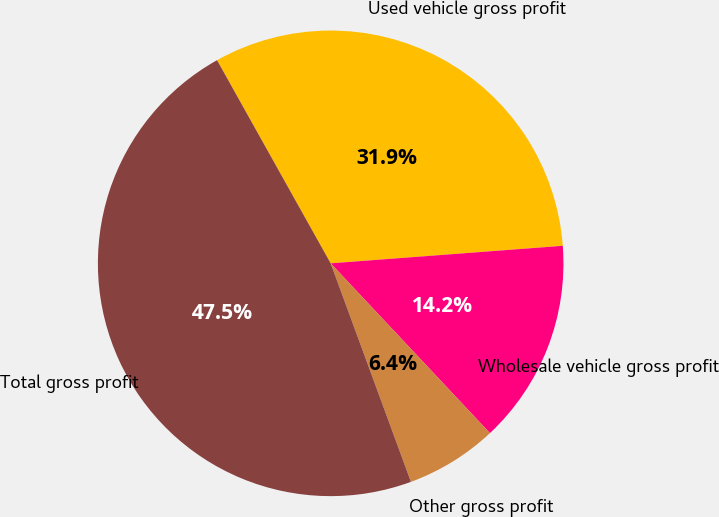Convert chart to OTSL. <chart><loc_0><loc_0><loc_500><loc_500><pie_chart><fcel>Used vehicle gross profit<fcel>Wholesale vehicle gross profit<fcel>Other gross profit<fcel>Total gross profit<nl><fcel>31.92%<fcel>14.21%<fcel>6.39%<fcel>47.49%<nl></chart> 